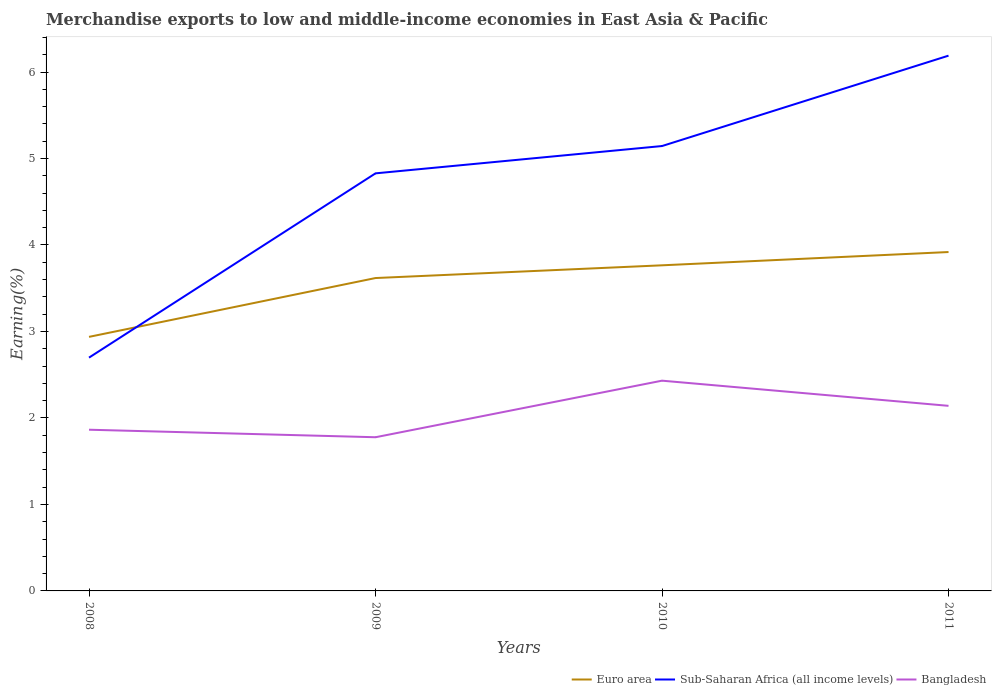Does the line corresponding to Sub-Saharan Africa (all income levels) intersect with the line corresponding to Bangladesh?
Offer a terse response. No. Is the number of lines equal to the number of legend labels?
Offer a terse response. Yes. Across all years, what is the maximum percentage of amount earned from merchandise exports in Bangladesh?
Offer a terse response. 1.78. What is the total percentage of amount earned from merchandise exports in Sub-Saharan Africa (all income levels) in the graph?
Provide a succinct answer. -1.05. What is the difference between the highest and the second highest percentage of amount earned from merchandise exports in Sub-Saharan Africa (all income levels)?
Provide a succinct answer. 3.49. What is the difference between the highest and the lowest percentage of amount earned from merchandise exports in Sub-Saharan Africa (all income levels)?
Ensure brevity in your answer.  3. Is the percentage of amount earned from merchandise exports in Euro area strictly greater than the percentage of amount earned from merchandise exports in Bangladesh over the years?
Your response must be concise. No. How many lines are there?
Offer a terse response. 3. What is the difference between two consecutive major ticks on the Y-axis?
Keep it short and to the point. 1. Are the values on the major ticks of Y-axis written in scientific E-notation?
Your response must be concise. No. Does the graph contain grids?
Your answer should be very brief. No. How many legend labels are there?
Offer a terse response. 3. How are the legend labels stacked?
Ensure brevity in your answer.  Horizontal. What is the title of the graph?
Your answer should be very brief. Merchandise exports to low and middle-income economies in East Asia & Pacific. What is the label or title of the Y-axis?
Ensure brevity in your answer.  Earning(%). What is the Earning(%) of Euro area in 2008?
Keep it short and to the point. 2.94. What is the Earning(%) of Sub-Saharan Africa (all income levels) in 2008?
Offer a terse response. 2.7. What is the Earning(%) of Bangladesh in 2008?
Your answer should be very brief. 1.86. What is the Earning(%) in Euro area in 2009?
Offer a very short reply. 3.62. What is the Earning(%) in Sub-Saharan Africa (all income levels) in 2009?
Give a very brief answer. 4.83. What is the Earning(%) of Bangladesh in 2009?
Offer a very short reply. 1.78. What is the Earning(%) in Euro area in 2010?
Offer a terse response. 3.76. What is the Earning(%) of Sub-Saharan Africa (all income levels) in 2010?
Your answer should be very brief. 5.14. What is the Earning(%) of Bangladesh in 2010?
Offer a terse response. 2.43. What is the Earning(%) in Euro area in 2011?
Your answer should be compact. 3.92. What is the Earning(%) of Sub-Saharan Africa (all income levels) in 2011?
Provide a short and direct response. 6.19. What is the Earning(%) of Bangladesh in 2011?
Provide a short and direct response. 2.14. Across all years, what is the maximum Earning(%) of Euro area?
Offer a terse response. 3.92. Across all years, what is the maximum Earning(%) in Sub-Saharan Africa (all income levels)?
Your answer should be compact. 6.19. Across all years, what is the maximum Earning(%) in Bangladesh?
Your answer should be very brief. 2.43. Across all years, what is the minimum Earning(%) of Euro area?
Keep it short and to the point. 2.94. Across all years, what is the minimum Earning(%) of Sub-Saharan Africa (all income levels)?
Your response must be concise. 2.7. Across all years, what is the minimum Earning(%) in Bangladesh?
Ensure brevity in your answer.  1.78. What is the total Earning(%) of Euro area in the graph?
Offer a very short reply. 14.24. What is the total Earning(%) in Sub-Saharan Africa (all income levels) in the graph?
Your response must be concise. 18.86. What is the total Earning(%) of Bangladesh in the graph?
Your answer should be compact. 8.21. What is the difference between the Earning(%) of Euro area in 2008 and that in 2009?
Keep it short and to the point. -0.68. What is the difference between the Earning(%) of Sub-Saharan Africa (all income levels) in 2008 and that in 2009?
Your answer should be compact. -2.13. What is the difference between the Earning(%) in Bangladesh in 2008 and that in 2009?
Give a very brief answer. 0.09. What is the difference between the Earning(%) of Euro area in 2008 and that in 2010?
Offer a terse response. -0.83. What is the difference between the Earning(%) in Sub-Saharan Africa (all income levels) in 2008 and that in 2010?
Provide a succinct answer. -2.45. What is the difference between the Earning(%) in Bangladesh in 2008 and that in 2010?
Make the answer very short. -0.57. What is the difference between the Earning(%) of Euro area in 2008 and that in 2011?
Provide a short and direct response. -0.98. What is the difference between the Earning(%) in Sub-Saharan Africa (all income levels) in 2008 and that in 2011?
Offer a very short reply. -3.49. What is the difference between the Earning(%) in Bangladesh in 2008 and that in 2011?
Offer a very short reply. -0.28. What is the difference between the Earning(%) of Euro area in 2009 and that in 2010?
Provide a succinct answer. -0.15. What is the difference between the Earning(%) in Sub-Saharan Africa (all income levels) in 2009 and that in 2010?
Provide a short and direct response. -0.32. What is the difference between the Earning(%) of Bangladesh in 2009 and that in 2010?
Your answer should be compact. -0.65. What is the difference between the Earning(%) of Euro area in 2009 and that in 2011?
Make the answer very short. -0.3. What is the difference between the Earning(%) in Sub-Saharan Africa (all income levels) in 2009 and that in 2011?
Provide a short and direct response. -1.36. What is the difference between the Earning(%) of Bangladesh in 2009 and that in 2011?
Ensure brevity in your answer.  -0.36. What is the difference between the Earning(%) of Euro area in 2010 and that in 2011?
Your answer should be very brief. -0.15. What is the difference between the Earning(%) of Sub-Saharan Africa (all income levels) in 2010 and that in 2011?
Your answer should be very brief. -1.05. What is the difference between the Earning(%) of Bangladesh in 2010 and that in 2011?
Offer a terse response. 0.29. What is the difference between the Earning(%) of Euro area in 2008 and the Earning(%) of Sub-Saharan Africa (all income levels) in 2009?
Offer a very short reply. -1.89. What is the difference between the Earning(%) of Euro area in 2008 and the Earning(%) of Bangladesh in 2009?
Give a very brief answer. 1.16. What is the difference between the Earning(%) of Sub-Saharan Africa (all income levels) in 2008 and the Earning(%) of Bangladesh in 2009?
Offer a terse response. 0.92. What is the difference between the Earning(%) of Euro area in 2008 and the Earning(%) of Sub-Saharan Africa (all income levels) in 2010?
Provide a short and direct response. -2.21. What is the difference between the Earning(%) in Euro area in 2008 and the Earning(%) in Bangladesh in 2010?
Provide a short and direct response. 0.51. What is the difference between the Earning(%) in Sub-Saharan Africa (all income levels) in 2008 and the Earning(%) in Bangladesh in 2010?
Keep it short and to the point. 0.27. What is the difference between the Earning(%) in Euro area in 2008 and the Earning(%) in Sub-Saharan Africa (all income levels) in 2011?
Your answer should be compact. -3.25. What is the difference between the Earning(%) of Euro area in 2008 and the Earning(%) of Bangladesh in 2011?
Your answer should be very brief. 0.8. What is the difference between the Earning(%) in Sub-Saharan Africa (all income levels) in 2008 and the Earning(%) in Bangladesh in 2011?
Make the answer very short. 0.56. What is the difference between the Earning(%) of Euro area in 2009 and the Earning(%) of Sub-Saharan Africa (all income levels) in 2010?
Make the answer very short. -1.53. What is the difference between the Earning(%) in Euro area in 2009 and the Earning(%) in Bangladesh in 2010?
Your answer should be very brief. 1.19. What is the difference between the Earning(%) of Sub-Saharan Africa (all income levels) in 2009 and the Earning(%) of Bangladesh in 2010?
Make the answer very short. 2.4. What is the difference between the Earning(%) of Euro area in 2009 and the Earning(%) of Sub-Saharan Africa (all income levels) in 2011?
Your answer should be very brief. -2.57. What is the difference between the Earning(%) in Euro area in 2009 and the Earning(%) in Bangladesh in 2011?
Provide a succinct answer. 1.48. What is the difference between the Earning(%) of Sub-Saharan Africa (all income levels) in 2009 and the Earning(%) of Bangladesh in 2011?
Ensure brevity in your answer.  2.69. What is the difference between the Earning(%) in Euro area in 2010 and the Earning(%) in Sub-Saharan Africa (all income levels) in 2011?
Provide a short and direct response. -2.42. What is the difference between the Earning(%) of Euro area in 2010 and the Earning(%) of Bangladesh in 2011?
Your answer should be compact. 1.62. What is the difference between the Earning(%) in Sub-Saharan Africa (all income levels) in 2010 and the Earning(%) in Bangladesh in 2011?
Make the answer very short. 3. What is the average Earning(%) in Euro area per year?
Your answer should be compact. 3.56. What is the average Earning(%) in Sub-Saharan Africa (all income levels) per year?
Your response must be concise. 4.71. What is the average Earning(%) of Bangladesh per year?
Provide a succinct answer. 2.05. In the year 2008, what is the difference between the Earning(%) in Euro area and Earning(%) in Sub-Saharan Africa (all income levels)?
Offer a terse response. 0.24. In the year 2008, what is the difference between the Earning(%) of Euro area and Earning(%) of Bangladesh?
Keep it short and to the point. 1.07. In the year 2008, what is the difference between the Earning(%) in Sub-Saharan Africa (all income levels) and Earning(%) in Bangladesh?
Offer a terse response. 0.83. In the year 2009, what is the difference between the Earning(%) of Euro area and Earning(%) of Sub-Saharan Africa (all income levels)?
Your answer should be compact. -1.21. In the year 2009, what is the difference between the Earning(%) of Euro area and Earning(%) of Bangladesh?
Your answer should be compact. 1.84. In the year 2009, what is the difference between the Earning(%) of Sub-Saharan Africa (all income levels) and Earning(%) of Bangladesh?
Provide a short and direct response. 3.05. In the year 2010, what is the difference between the Earning(%) in Euro area and Earning(%) in Sub-Saharan Africa (all income levels)?
Make the answer very short. -1.38. In the year 2010, what is the difference between the Earning(%) of Euro area and Earning(%) of Bangladesh?
Keep it short and to the point. 1.33. In the year 2010, what is the difference between the Earning(%) of Sub-Saharan Africa (all income levels) and Earning(%) of Bangladesh?
Offer a terse response. 2.71. In the year 2011, what is the difference between the Earning(%) of Euro area and Earning(%) of Sub-Saharan Africa (all income levels)?
Ensure brevity in your answer.  -2.27. In the year 2011, what is the difference between the Earning(%) of Euro area and Earning(%) of Bangladesh?
Keep it short and to the point. 1.78. In the year 2011, what is the difference between the Earning(%) of Sub-Saharan Africa (all income levels) and Earning(%) of Bangladesh?
Give a very brief answer. 4.05. What is the ratio of the Earning(%) of Euro area in 2008 to that in 2009?
Ensure brevity in your answer.  0.81. What is the ratio of the Earning(%) in Sub-Saharan Africa (all income levels) in 2008 to that in 2009?
Ensure brevity in your answer.  0.56. What is the ratio of the Earning(%) in Bangladesh in 2008 to that in 2009?
Your answer should be compact. 1.05. What is the ratio of the Earning(%) of Euro area in 2008 to that in 2010?
Provide a short and direct response. 0.78. What is the ratio of the Earning(%) of Sub-Saharan Africa (all income levels) in 2008 to that in 2010?
Your response must be concise. 0.52. What is the ratio of the Earning(%) of Bangladesh in 2008 to that in 2010?
Make the answer very short. 0.77. What is the ratio of the Earning(%) of Euro area in 2008 to that in 2011?
Your answer should be very brief. 0.75. What is the ratio of the Earning(%) of Sub-Saharan Africa (all income levels) in 2008 to that in 2011?
Ensure brevity in your answer.  0.44. What is the ratio of the Earning(%) in Bangladesh in 2008 to that in 2011?
Ensure brevity in your answer.  0.87. What is the ratio of the Earning(%) in Euro area in 2009 to that in 2010?
Give a very brief answer. 0.96. What is the ratio of the Earning(%) in Sub-Saharan Africa (all income levels) in 2009 to that in 2010?
Give a very brief answer. 0.94. What is the ratio of the Earning(%) in Bangladesh in 2009 to that in 2010?
Provide a succinct answer. 0.73. What is the ratio of the Earning(%) of Euro area in 2009 to that in 2011?
Your answer should be compact. 0.92. What is the ratio of the Earning(%) in Sub-Saharan Africa (all income levels) in 2009 to that in 2011?
Provide a short and direct response. 0.78. What is the ratio of the Earning(%) of Bangladesh in 2009 to that in 2011?
Offer a very short reply. 0.83. What is the ratio of the Earning(%) of Euro area in 2010 to that in 2011?
Provide a short and direct response. 0.96. What is the ratio of the Earning(%) of Sub-Saharan Africa (all income levels) in 2010 to that in 2011?
Offer a very short reply. 0.83. What is the ratio of the Earning(%) in Bangladesh in 2010 to that in 2011?
Give a very brief answer. 1.14. What is the difference between the highest and the second highest Earning(%) in Euro area?
Give a very brief answer. 0.15. What is the difference between the highest and the second highest Earning(%) of Sub-Saharan Africa (all income levels)?
Offer a very short reply. 1.05. What is the difference between the highest and the second highest Earning(%) of Bangladesh?
Ensure brevity in your answer.  0.29. What is the difference between the highest and the lowest Earning(%) in Sub-Saharan Africa (all income levels)?
Your answer should be compact. 3.49. What is the difference between the highest and the lowest Earning(%) of Bangladesh?
Your answer should be very brief. 0.65. 